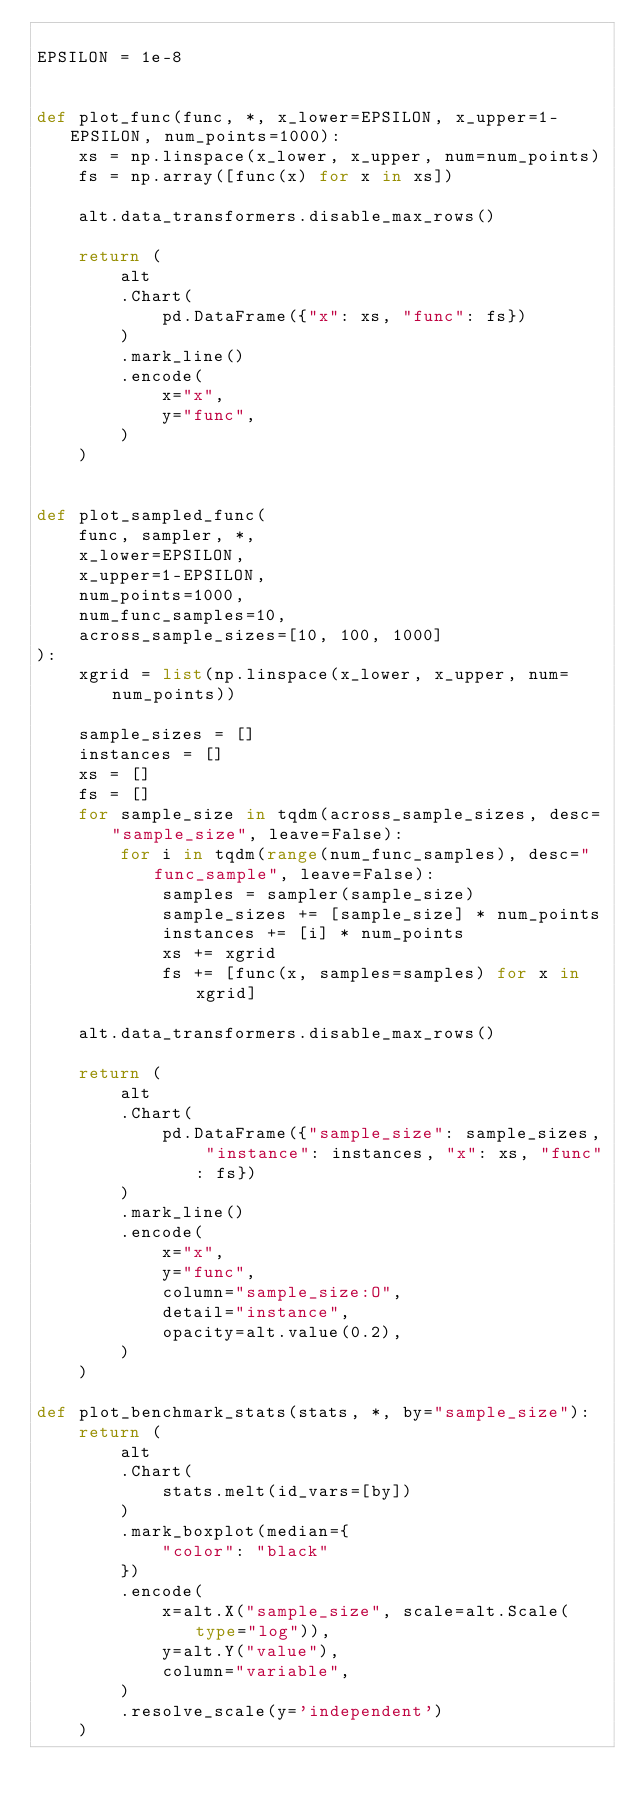Convert code to text. <code><loc_0><loc_0><loc_500><loc_500><_Python_>
EPSILON = 1e-8


def plot_func(func, *, x_lower=EPSILON, x_upper=1-EPSILON, num_points=1000):
    xs = np.linspace(x_lower, x_upper, num=num_points)
    fs = np.array([func(x) for x in xs])
    
    alt.data_transformers.disable_max_rows()

    return (
        alt
        .Chart(
            pd.DataFrame({"x": xs, "func": fs})
        )
        .mark_line()
        .encode(
            x="x",
            y="func",
        )
    )


def plot_sampled_func(
    func, sampler, *,
    x_lower=EPSILON,
    x_upper=1-EPSILON,
    num_points=1000,
    num_func_samples=10, 
    across_sample_sizes=[10, 100, 1000]
):
    xgrid = list(np.linspace(x_lower, x_upper, num=num_points))

    sample_sizes = []
    instances = []
    xs = []
    fs = []
    for sample_size in tqdm(across_sample_sizes, desc="sample_size", leave=False):
        for i in tqdm(range(num_func_samples), desc="func_sample", leave=False):
            samples = sampler(sample_size)
            sample_sizes += [sample_size] * num_points
            instances += [i] * num_points
            xs += xgrid
            fs += [func(x, samples=samples) for x in xgrid]
    
    alt.data_transformers.disable_max_rows()

    return (
        alt
        .Chart(
            pd.DataFrame({"sample_size": sample_sizes, "instance": instances, "x": xs, "func": fs})
        )
        .mark_line()
        .encode(
            x="x",
            y="func",
            column="sample_size:O",
            detail="instance",
            opacity=alt.value(0.2),
        )
    )

def plot_benchmark_stats(stats, *, by="sample_size"):
    return (
        alt
        .Chart(
            stats.melt(id_vars=[by])
        )
        .mark_boxplot(median={
            "color": "black"
        })
        .encode(
            x=alt.X("sample_size", scale=alt.Scale(type="log")),
            y=alt.Y("value"),
            column="variable",
        )
        .resolve_scale(y='independent')
    )
</code> 